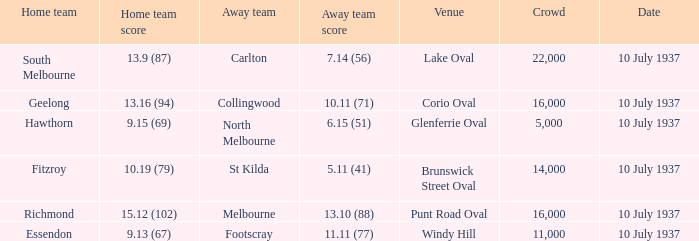What was the lowest Crowd during the Away Team Score of 10.11 (71)? 16000.0. 